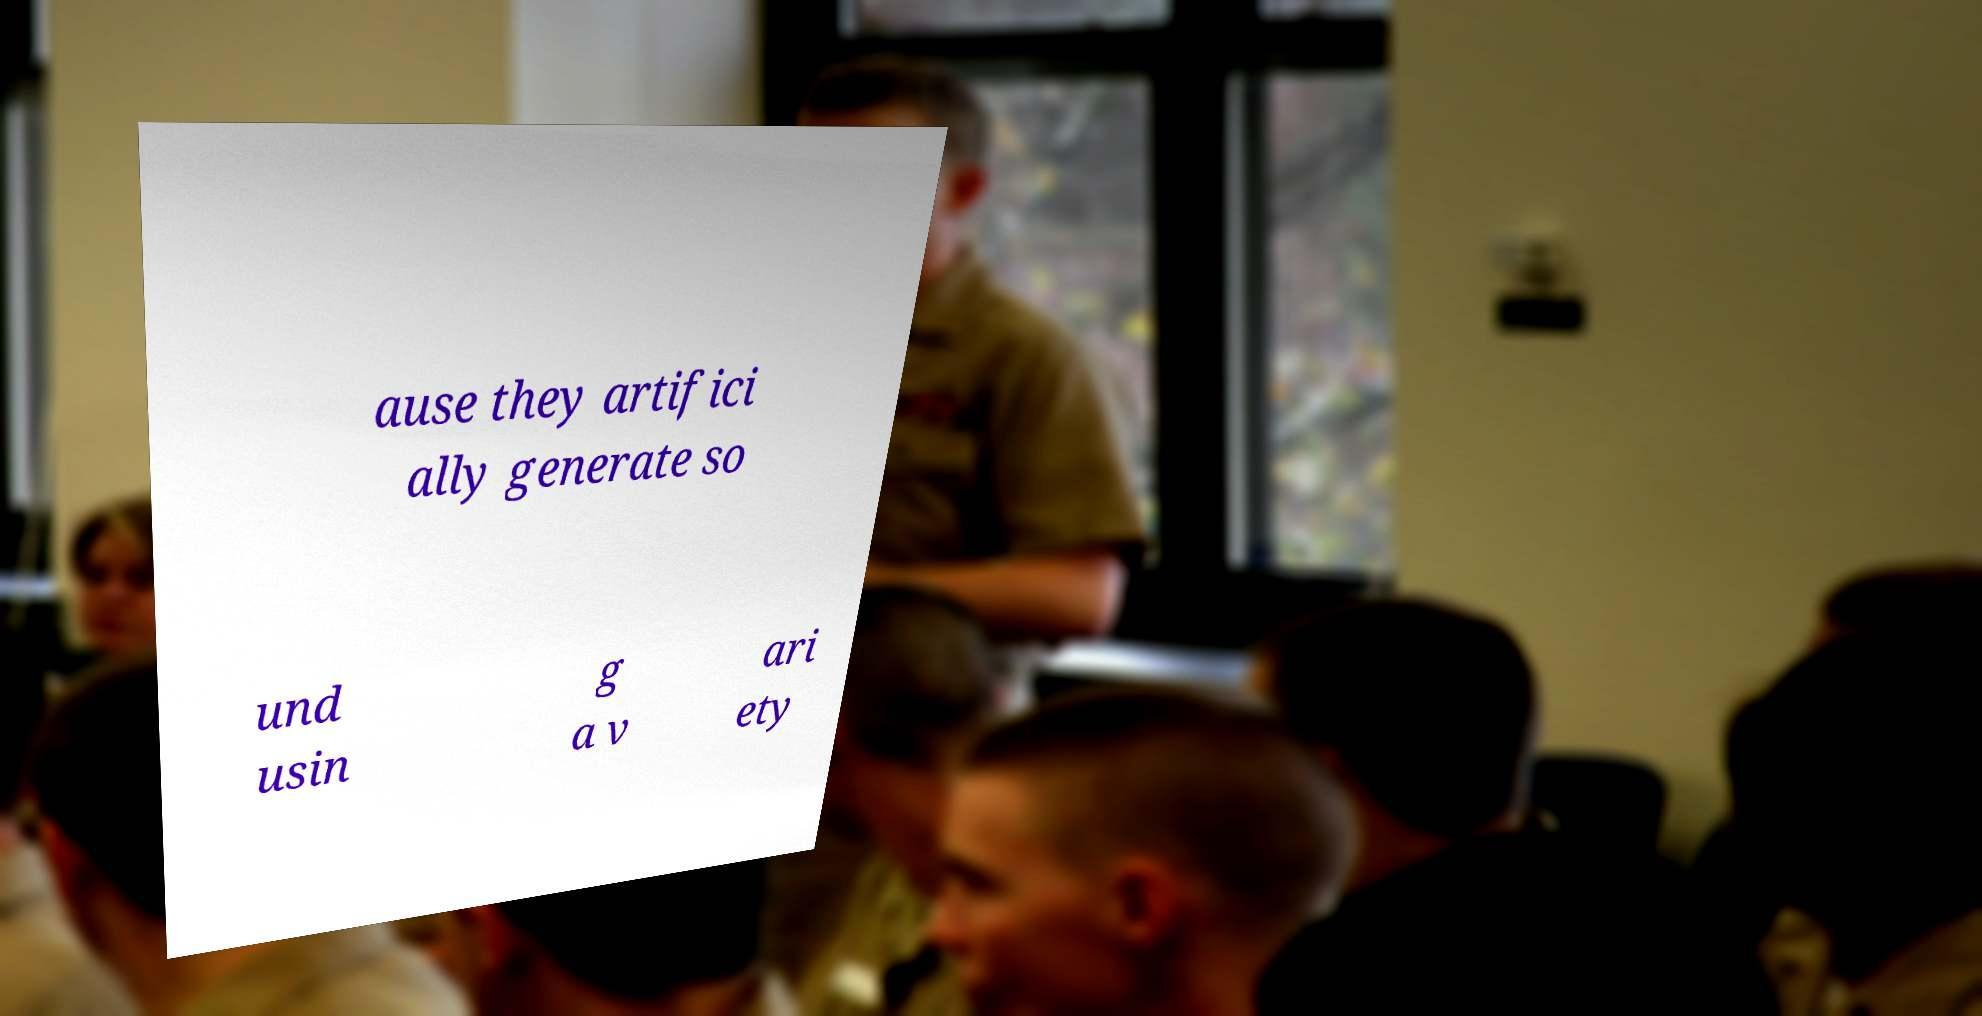Could you extract and type out the text from this image? ause they artifici ally generate so und usin g a v ari ety 